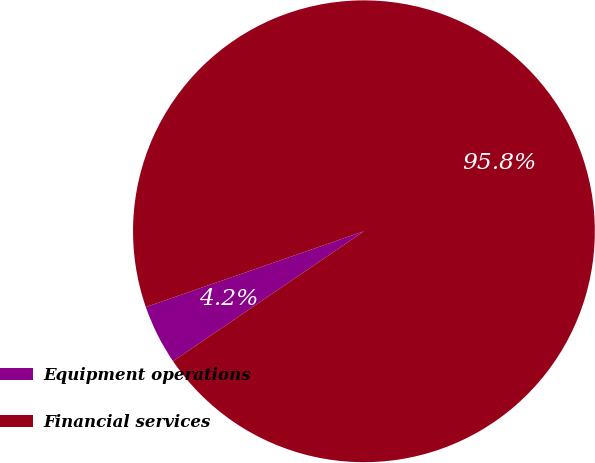<chart> <loc_0><loc_0><loc_500><loc_500><pie_chart><fcel>Equipment operations<fcel>Financial services<nl><fcel>4.19%<fcel>95.81%<nl></chart> 